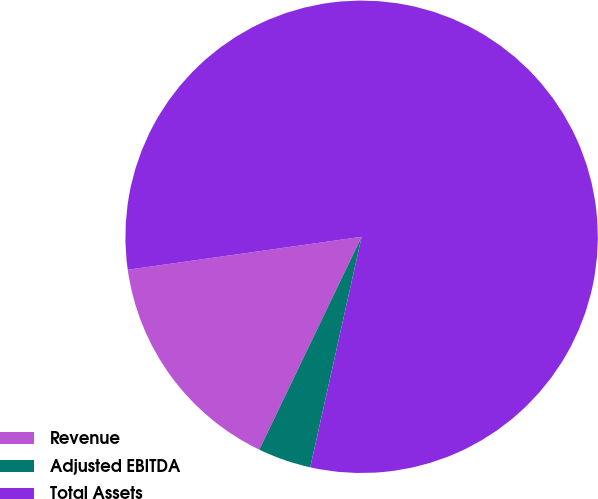Convert chart. <chart><loc_0><loc_0><loc_500><loc_500><pie_chart><fcel>Revenue<fcel>Adjusted EBITDA<fcel>Total Assets<nl><fcel>15.64%<fcel>3.64%<fcel>80.72%<nl></chart> 